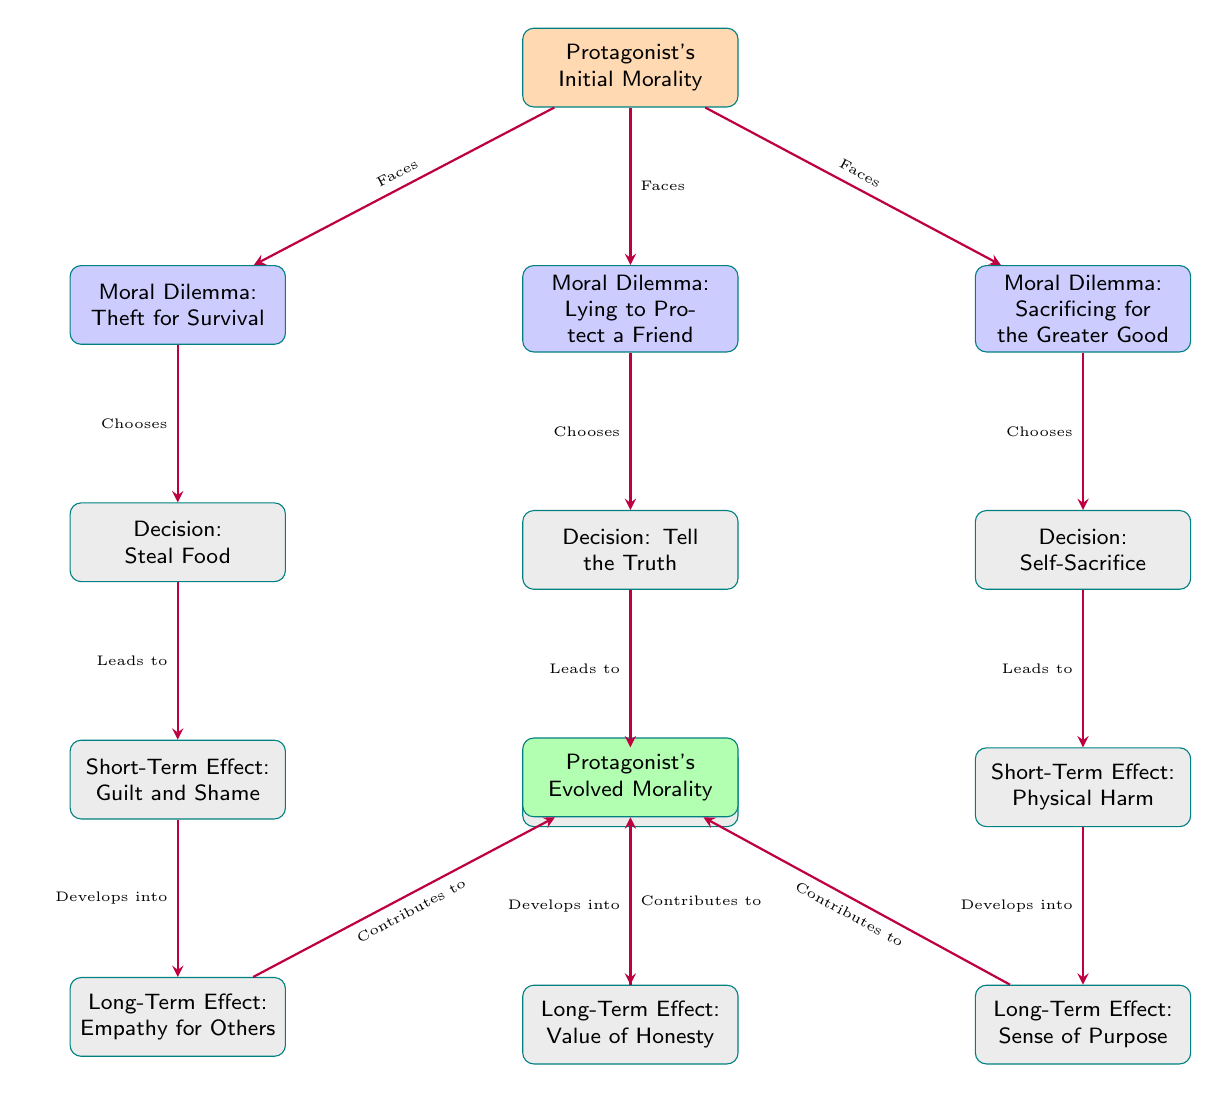What is the protagonist's initial morality? The diagram indicates that the protagonist's initial morality is the starting point from which various moral dilemmas are addressed. This node is labeled "Protagonist's Initial Morality."
Answer: Protagonist's Initial Morality What is the decision made in response to the moral dilemma of theft for survival? The diagram shows, under the moral dilemma of theft for survival, the decision made is "Steal Food." This is derived directly from the flow of the arrows leading to that node.
Answer: Steal Food What is the long-term effect of the decision to lie to protect a friend? Following the flow from the decision "Tell the Truth" in the lying dilemma, we see it leads to a long-term effect labeled "Value of Honesty." This is established by tracing the arrows moving downwards from the decision.
Answer: Value of Honesty How does the short-term effect of stealing food develop? Starting from "Steal Food," it leads to the short-term effect of "Guilt and Shame," which then develops into a long-term effect of "Empathy for Others." This progression indicates a cause-and-effect relationship influenced by the initial decision.
Answer: Empathy for Others Which moral dilemma results in a sense of purpose? According to the diagram, the moral dilemma "Sacrificing for the Greater Good" results in the long-term effect of "Sense of Purpose." The connections show that this is a direct outcome of the choices made in the corresponding situation.
Answer: Sacrificing for the Greater Good What connects the short-term effect of physical harm to the protagonist's evolved morality? The flow shows that the short-term effect "Physical Harm" from the decision to "Self-Sacrifice" contributes to the protagonist's evolved morality through the arrow indicating a positive developmental effect.
Answer: Contributes to How many total moral dilemmas are shown in the diagram? By counting the moral dilemmas presented in the diagram, we find three: Theft for Survival, Lying to Protect a Friend, and Sacrificing for the Greater Good. Each is distinctly initiated from the protagonist's initial morality.
Answer: Three What is the relationship between short-term effects and long-term effects in moral dilemmas? Each short-term effect, like "Guilt and Shame" and "Loss of Friendship," develops into a corresponding long-term effect, indicating a clear cause-and-effect relationship. This is reflected in how each node leads to the next through the directed arrows.
Answer: Develops into What are the colors of the nodes representing moral dilemmas? The nodes indicating moral dilemmas (Theft for Survival, Lying to Protect a Friend, Sacrificing for the Greater Good) are filled with a blue shade, as shown by the diagram’s color coding.
Answer: Blue!20 